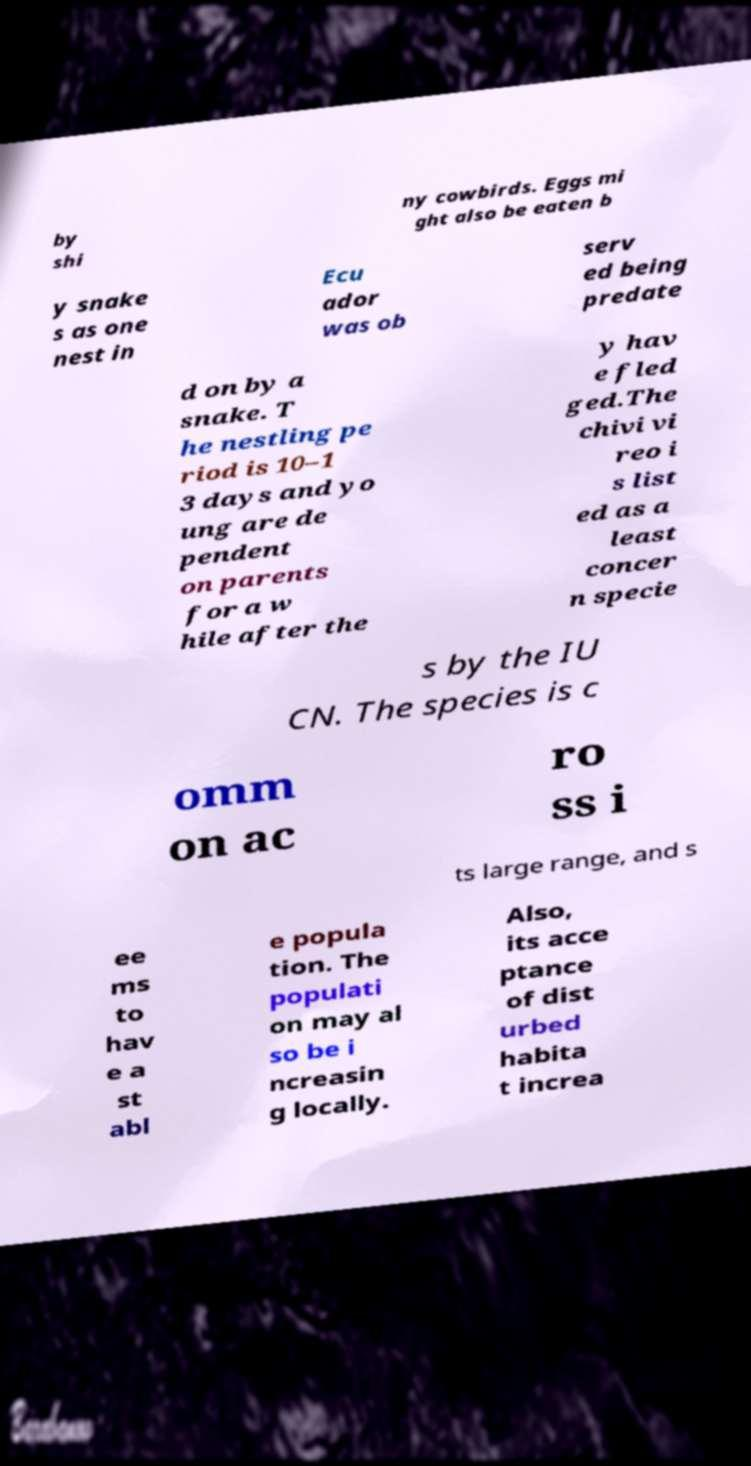Please identify and transcribe the text found in this image. by shi ny cowbirds. Eggs mi ght also be eaten b y snake s as one nest in Ecu ador was ob serv ed being predate d on by a snake. T he nestling pe riod is 10–1 3 days and yo ung are de pendent on parents for a w hile after the y hav e fled ged.The chivi vi reo i s list ed as a least concer n specie s by the IU CN. The species is c omm on ac ro ss i ts large range, and s ee ms to hav e a st abl e popula tion. The populati on may al so be i ncreasin g locally. Also, its acce ptance of dist urbed habita t increa 